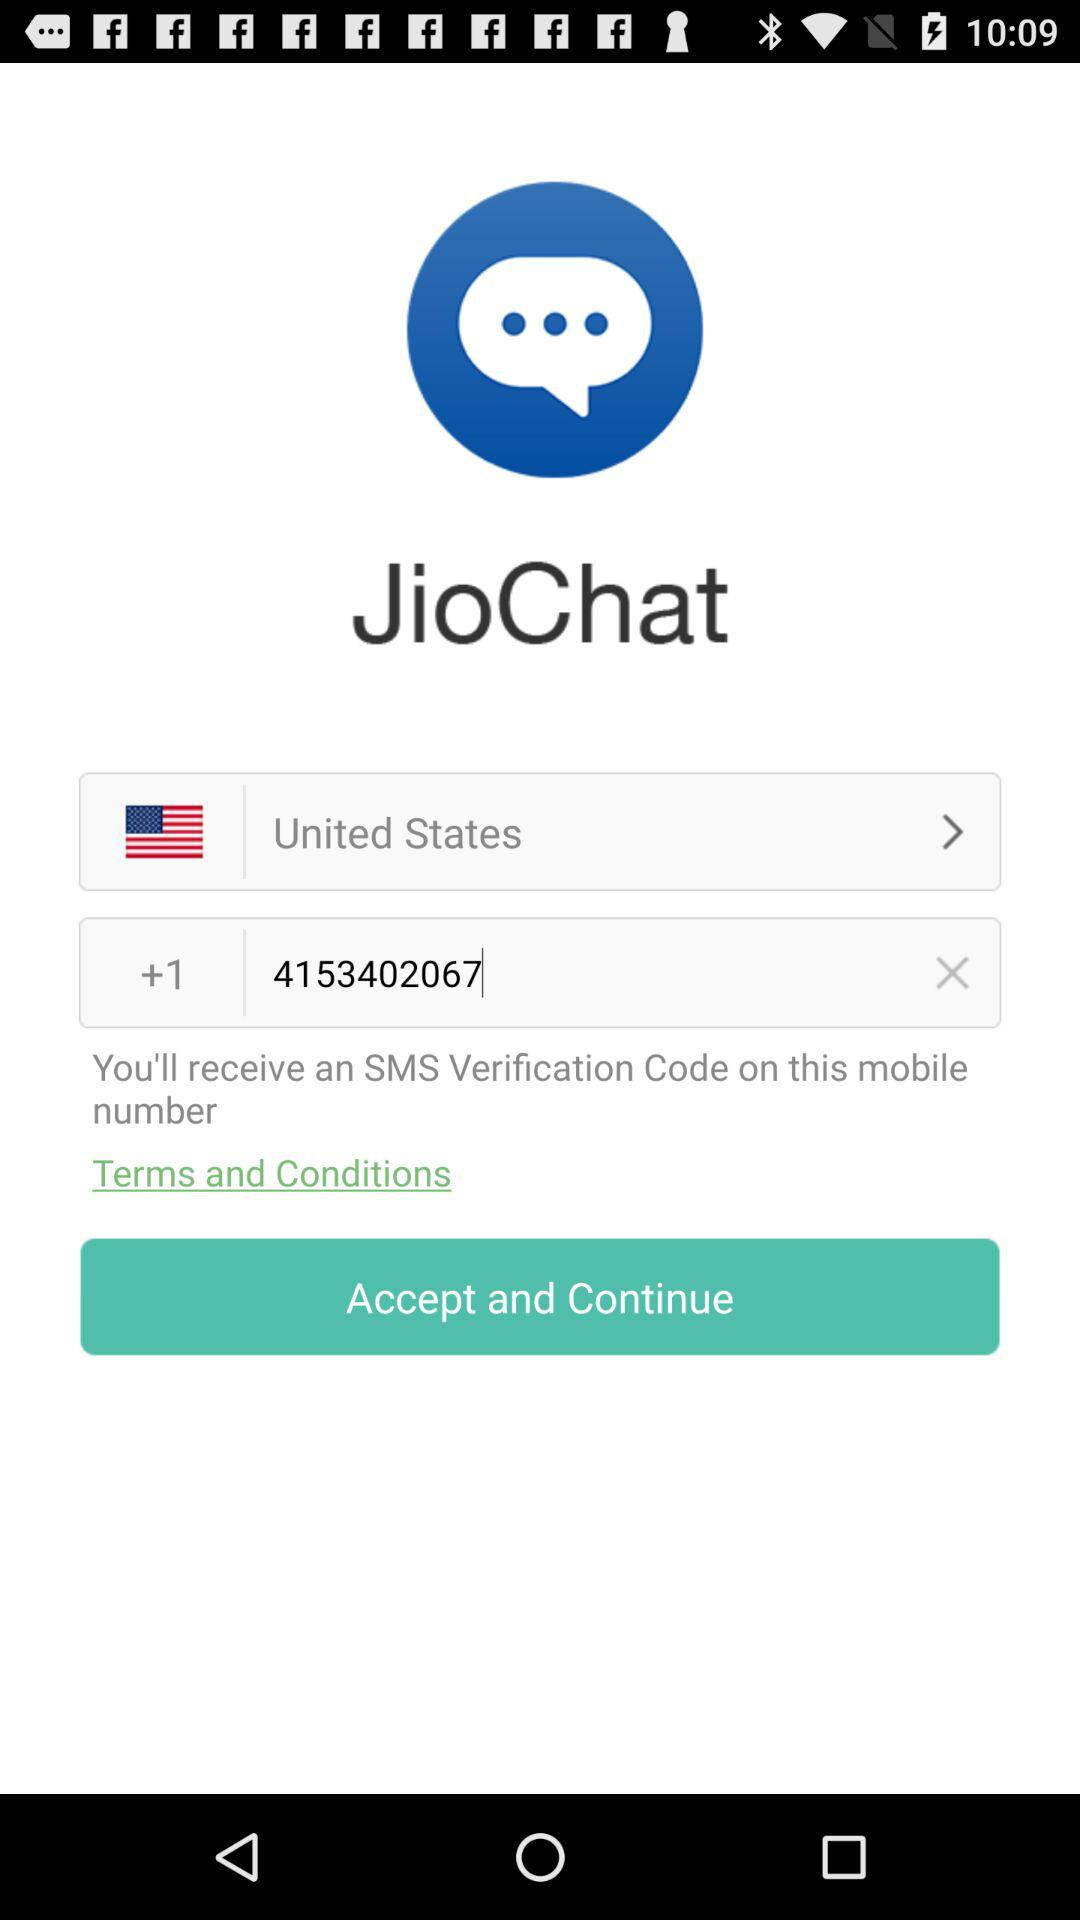What is the contact number? The contact number is +1 4153402067. 